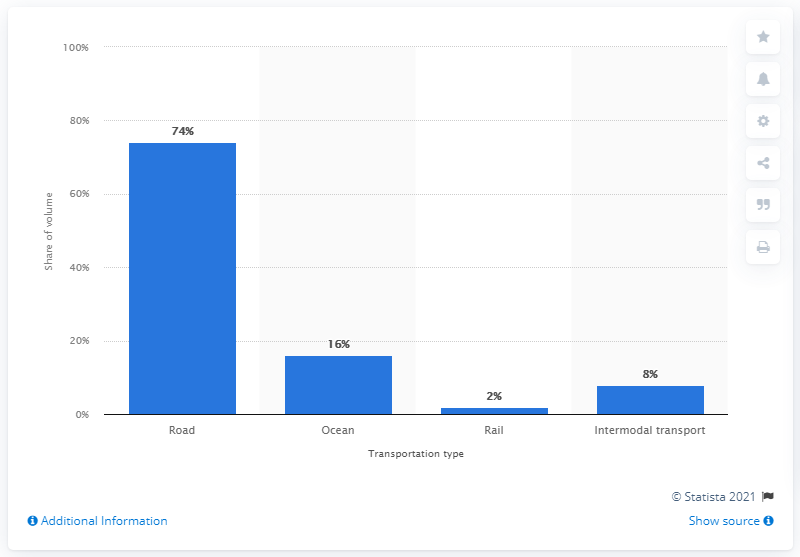Highlight a few significant elements in this photo. In 2011, the share of IKEA goods transported by road was 74%. 